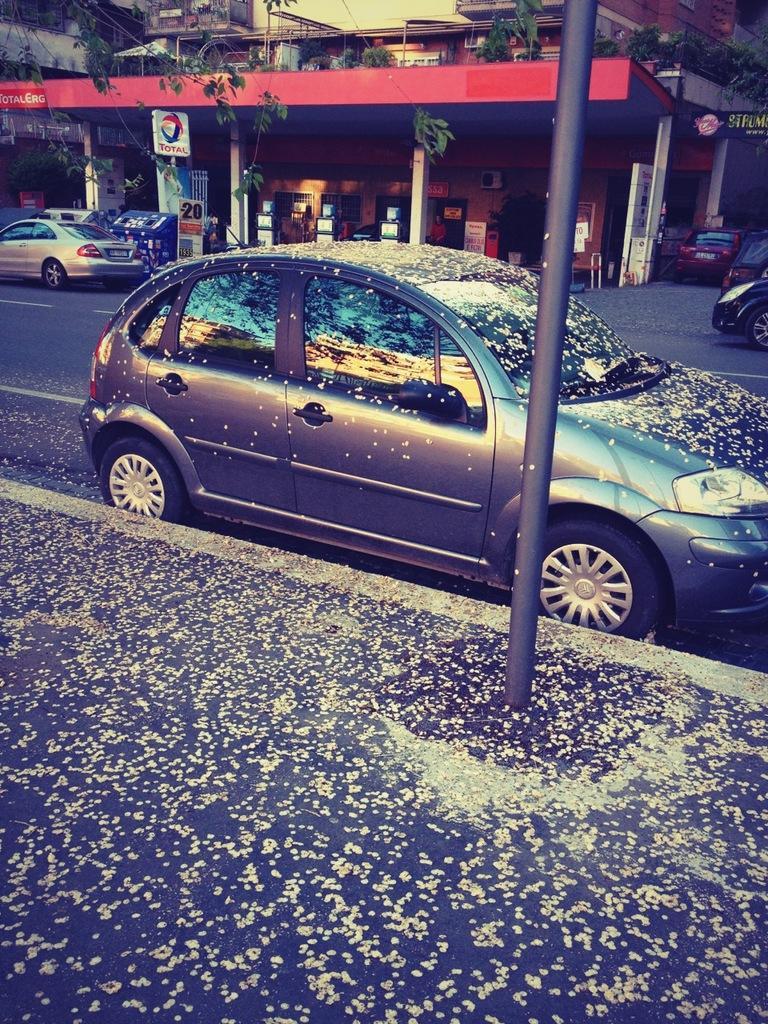How would you summarize this image in a sentence or two? In the center of the image there is a car on the road. In the background we can see buildings, pillars, cars, trees, plants and board. 